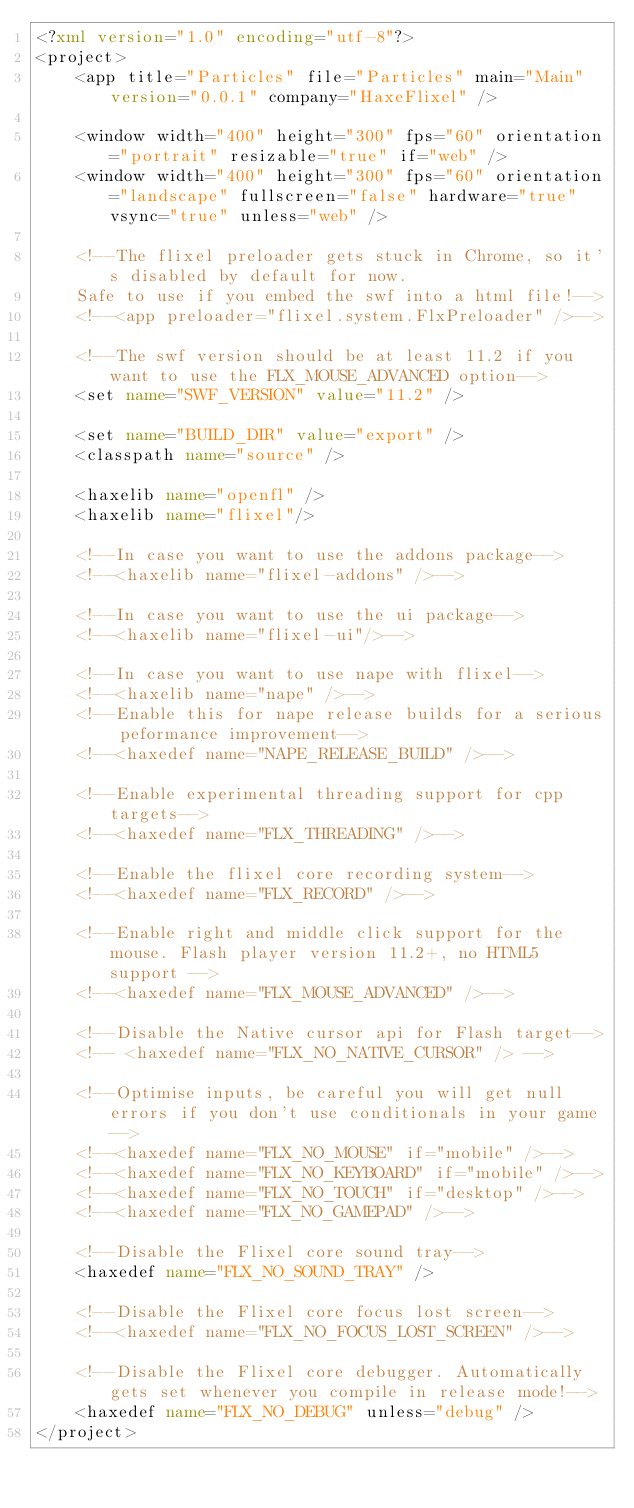<code> <loc_0><loc_0><loc_500><loc_500><_XML_><?xml version="1.0" encoding="utf-8"?>
<project>
	<app title="Particles" file="Particles" main="Main" version="0.0.1" company="HaxeFlixel" />
	
	<window width="400" height="300" fps="60" orientation="portrait" resizable="true" if="web" />
	<window width="400" height="300" fps="60" orientation="landscape" fullscreen="false" hardware="true" vsync="true" unless="web" />
	
	<!--The flixel preloader gets stuck in Chrome, so it's disabled by default for now. 
	Safe to use if you embed the swf into a html file!-->
	<!--<app preloader="flixel.system.FlxPreloader" />-->
	
	<!--The swf version should be at least 11.2 if you want to use the FLX_MOUSE_ADVANCED option-->
	<set name="SWF_VERSION" value="11.2" />
	
	<set name="BUILD_DIR" value="export" />
	<classpath name="source" />
	
	<haxelib name="openfl" />
	<haxelib name="flixel"/>
	
	<!--In case you want to use the addons package-->
	<!--<haxelib name="flixel-addons" />-->
	
	<!--In case you want to use the ui package-->
	<!--<haxelib name="flixel-ui"/>-->
	
	<!--In case you want to use nape with flixel-->
	<!--<haxelib name="nape" />-->
	<!--Enable this for nape release builds for a serious peformance improvement-->
	<!--<haxedef name="NAPE_RELEASE_BUILD" />--> 
	
	<!--Enable experimental threading support for cpp targets-->
	<!--<haxedef name="FLX_THREADING" />-->
	
	<!--Enable the flixel core recording system-->
	<!--<haxedef name="FLX_RECORD" />-->
	
	<!--Enable right and middle click support for the mouse. Flash player version 11.2+, no HTML5 support -->
	<!--<haxedef name="FLX_MOUSE_ADVANCED" />-->
	
	<!--Disable the Native cursor api for Flash target-->
	<!-- <haxedef name="FLX_NO_NATIVE_CURSOR" /> -->
	
	<!--Optimise inputs, be careful you will get null errors if you don't use conditionals in your game-->
	<!--<haxedef name="FLX_NO_MOUSE" if="mobile" />-->
	<!--<haxedef name="FLX_NO_KEYBOARD" if="mobile" />-->
	<!--<haxedef name="FLX_NO_TOUCH" if="desktop" />-->
	<!--<haxedef name="FLX_NO_GAMEPAD" />-->
	
	<!--Disable the Flixel core sound tray-->
	<haxedef name="FLX_NO_SOUND_TRAY" />
	
	<!--Disable the Flixel core focus lost screen-->
	<!--<haxedef name="FLX_NO_FOCUS_LOST_SCREEN" />-->
	
	<!--Disable the Flixel core debugger. Automatically gets set whenever you compile in release mode!-->
	<haxedef name="FLX_NO_DEBUG" unless="debug" />
</project></code> 